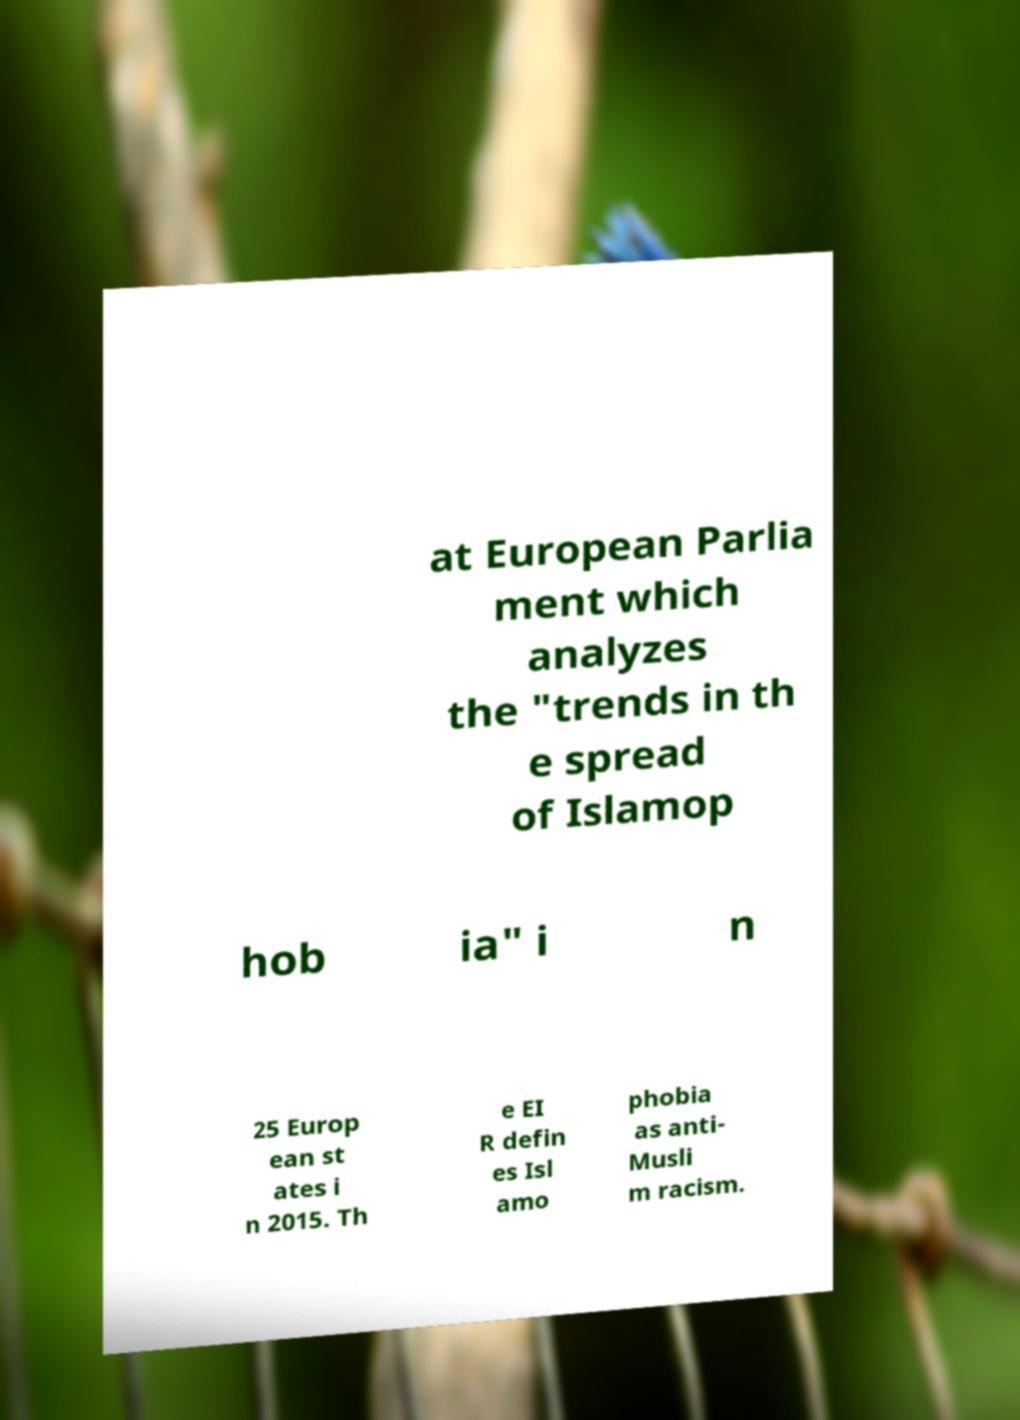There's text embedded in this image that I need extracted. Can you transcribe it verbatim? at European Parlia ment which analyzes the "trends in th e spread of Islamop hob ia" i n 25 Europ ean st ates i n 2015. Th e EI R defin es Isl amo phobia as anti- Musli m racism. 